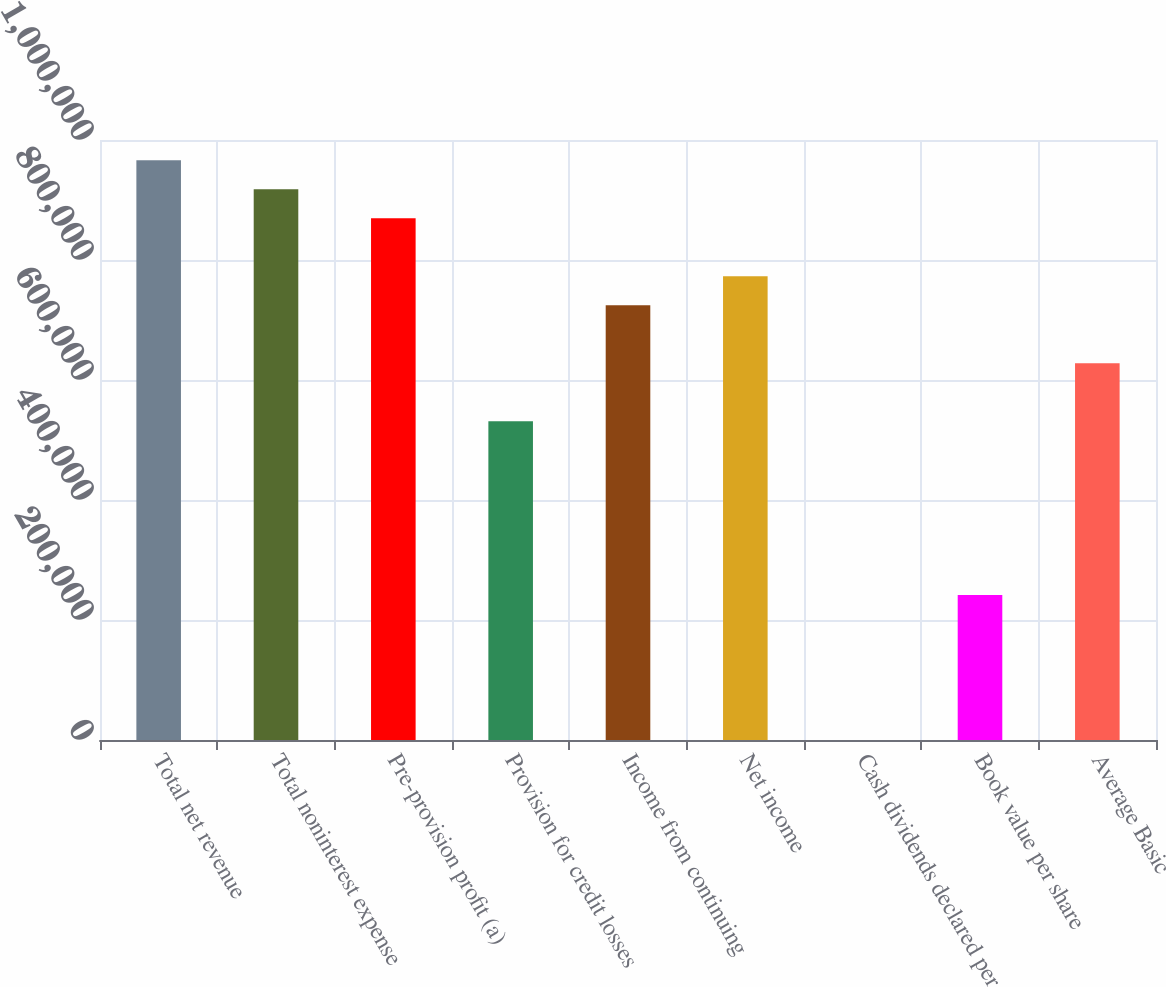<chart> <loc_0><loc_0><loc_500><loc_500><bar_chart><fcel>Total net revenue<fcel>Total noninterest expense<fcel>Pre-provision profit (a)<fcel>Provision for credit losses<fcel>Income from continuing<fcel>Net income<fcel>Cash dividends declared per<fcel>Book value per share<fcel>Average Basic<nl><fcel>966253<fcel>917940<fcel>869627<fcel>531440<fcel>724690<fcel>773002<fcel>1.36<fcel>241564<fcel>628065<nl></chart> 